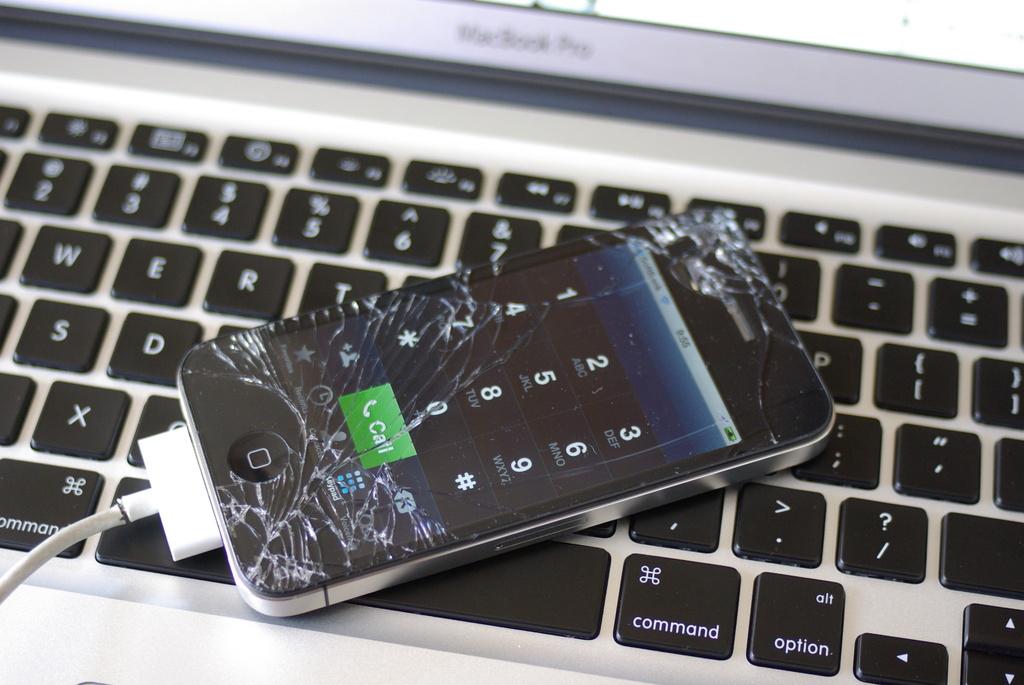What kind of computer is this?
Your answer should be very brief. Macbook pro. What does it say in the green box on the phone?
Your answer should be very brief. Call. 